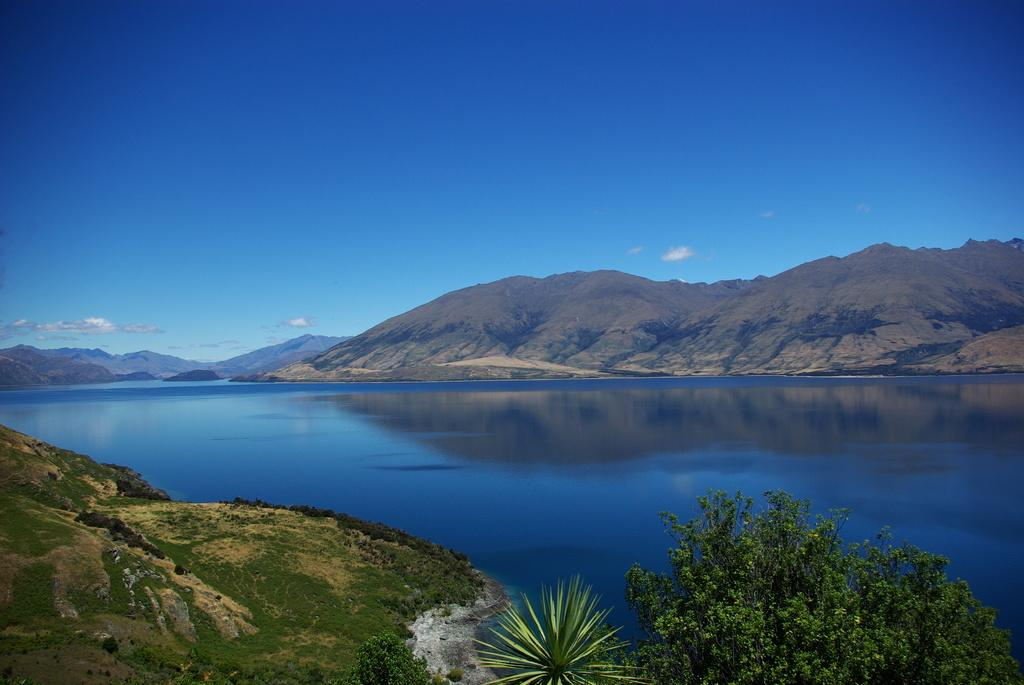What can be seen in the foreground of the picture? There are trees and hills in the foreground of the picture. What is located in the center of the picture? There is a water body in the center of the picture. What is visible in the background of the picture? There are mountains and hills in the background of the picture. How would you describe the weather in the image? The sky is sunny, which suggests a clear and bright day. What type of flesh can be seen hanging from the trees in the image? There is no flesh hanging from the trees in the image; it features trees, hills, a water body, and mountains. Is there a minister present in the image? There is no minister present in the image. 